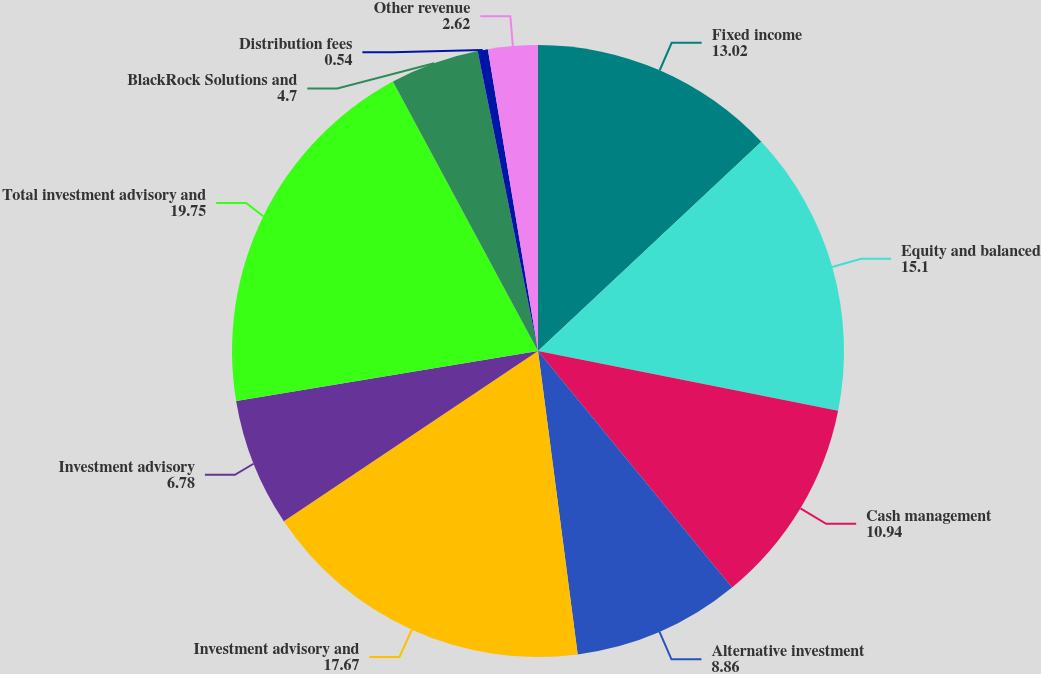Convert chart to OTSL. <chart><loc_0><loc_0><loc_500><loc_500><pie_chart><fcel>Fixed income<fcel>Equity and balanced<fcel>Cash management<fcel>Alternative investment<fcel>Investment advisory and<fcel>Investment advisory<fcel>Total investment advisory and<fcel>BlackRock Solutions and<fcel>Distribution fees<fcel>Other revenue<nl><fcel>13.02%<fcel>15.1%<fcel>10.94%<fcel>8.86%<fcel>17.67%<fcel>6.78%<fcel>19.75%<fcel>4.7%<fcel>0.54%<fcel>2.62%<nl></chart> 